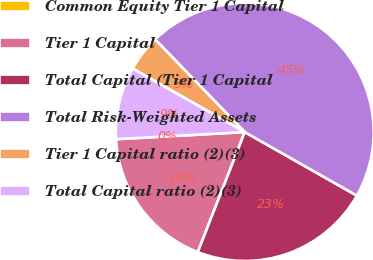<chart> <loc_0><loc_0><loc_500><loc_500><pie_chart><fcel>Common Equity Tier 1 Capital<fcel>Tier 1 Capital<fcel>Total Capital (Tier 1 Capital<fcel>Total Risk-Weighted Assets<fcel>Tier 1 Capital ratio (2)(3)<fcel>Total Capital ratio (2)(3)<nl><fcel>0.0%<fcel>18.18%<fcel>22.73%<fcel>45.45%<fcel>4.55%<fcel>9.09%<nl></chart> 